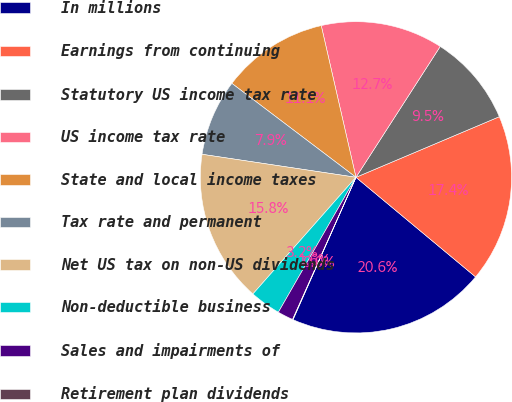Convert chart. <chart><loc_0><loc_0><loc_500><loc_500><pie_chart><fcel>In millions<fcel>Earnings from continuing<fcel>Statutory US income tax rate<fcel>US income tax rate<fcel>State and local income taxes<fcel>Tax rate and permanent<fcel>Net US tax on non-US dividends<fcel>Non-deductible business<fcel>Sales and impairments of<fcel>Retirement plan dividends<nl><fcel>20.58%<fcel>17.42%<fcel>9.53%<fcel>12.69%<fcel>11.11%<fcel>7.95%<fcel>15.85%<fcel>3.21%<fcel>1.63%<fcel>0.05%<nl></chart> 